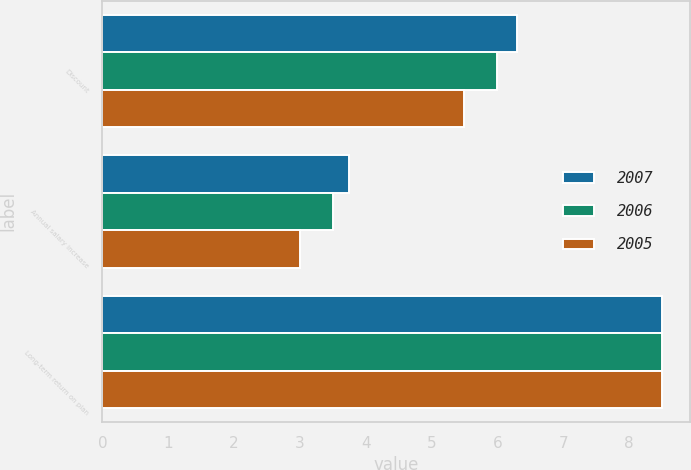Convert chart. <chart><loc_0><loc_0><loc_500><loc_500><stacked_bar_chart><ecel><fcel>Discount<fcel>Annual salary increase<fcel>Long-term return on plan<nl><fcel>2007<fcel>6.3<fcel>3.75<fcel>8.5<nl><fcel>2006<fcel>6<fcel>3.5<fcel>8.5<nl><fcel>2005<fcel>5.5<fcel>3<fcel>8.5<nl></chart> 